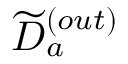<formula> <loc_0><loc_0><loc_500><loc_500>{ \widetilde { D } } _ { a } ^ { ( o u t ) }</formula> 